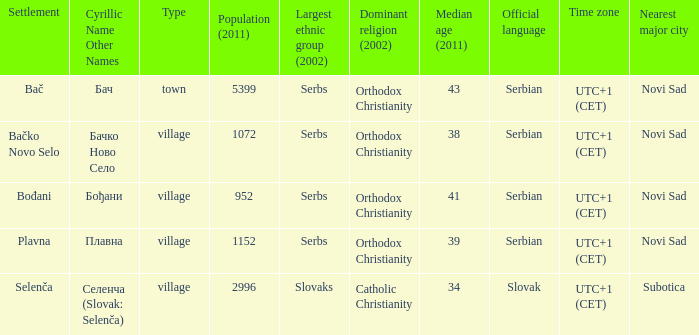How to you write  плавна with the latin alphabet? Plavna. 